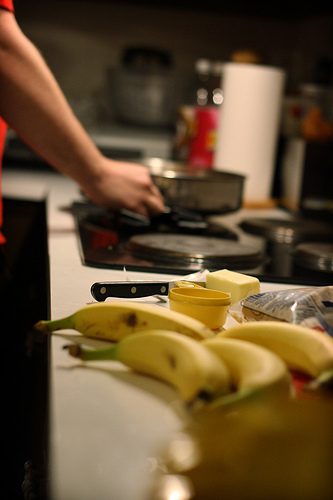What kind of meal might be being prepared in the image? Given the bananas and the style of cooking, it could be a breakfast or a dessert preparation, possibly involving warm meals like oatmeal or a banana-based dish. 